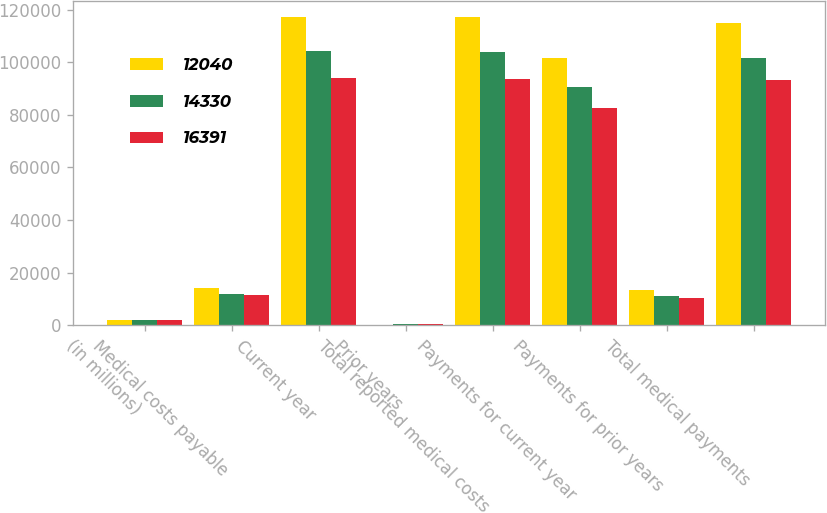Convert chart. <chart><loc_0><loc_0><loc_500><loc_500><stacked_bar_chart><ecel><fcel>(in millions)<fcel>Medical costs payable<fcel>Current year<fcel>Prior years<fcel>Total reported medical costs<fcel>Payments for current year<fcel>Payments for prior years<fcel>Total medical payments<nl><fcel>12040<fcel>2016<fcel>14330<fcel>117258<fcel>220<fcel>117038<fcel>101696<fcel>13281<fcel>114977<nl><fcel>14330<fcel>2015<fcel>12040<fcel>104195<fcel>320<fcel>103875<fcel>90630<fcel>10955<fcel>101585<nl><fcel>16391<fcel>2014<fcel>11575<fcel>94053<fcel>420<fcel>93633<fcel>82750<fcel>10418<fcel>93168<nl></chart> 